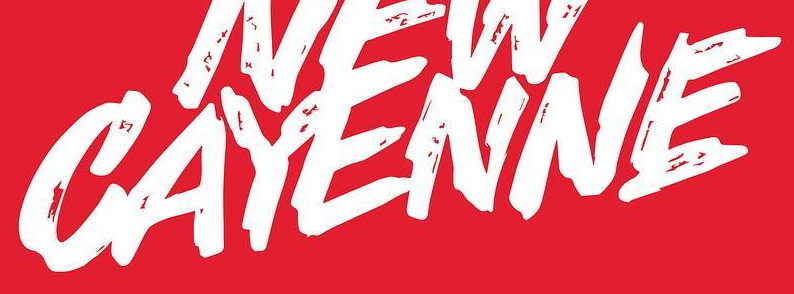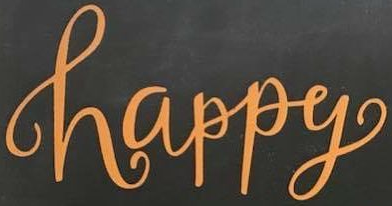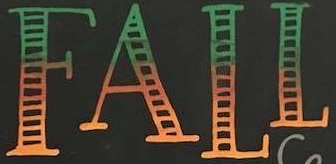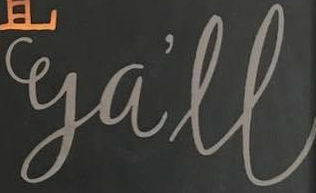What words can you see in these images in sequence, separated by a semicolon? CAYENNE; happy; FALL; ga'll 